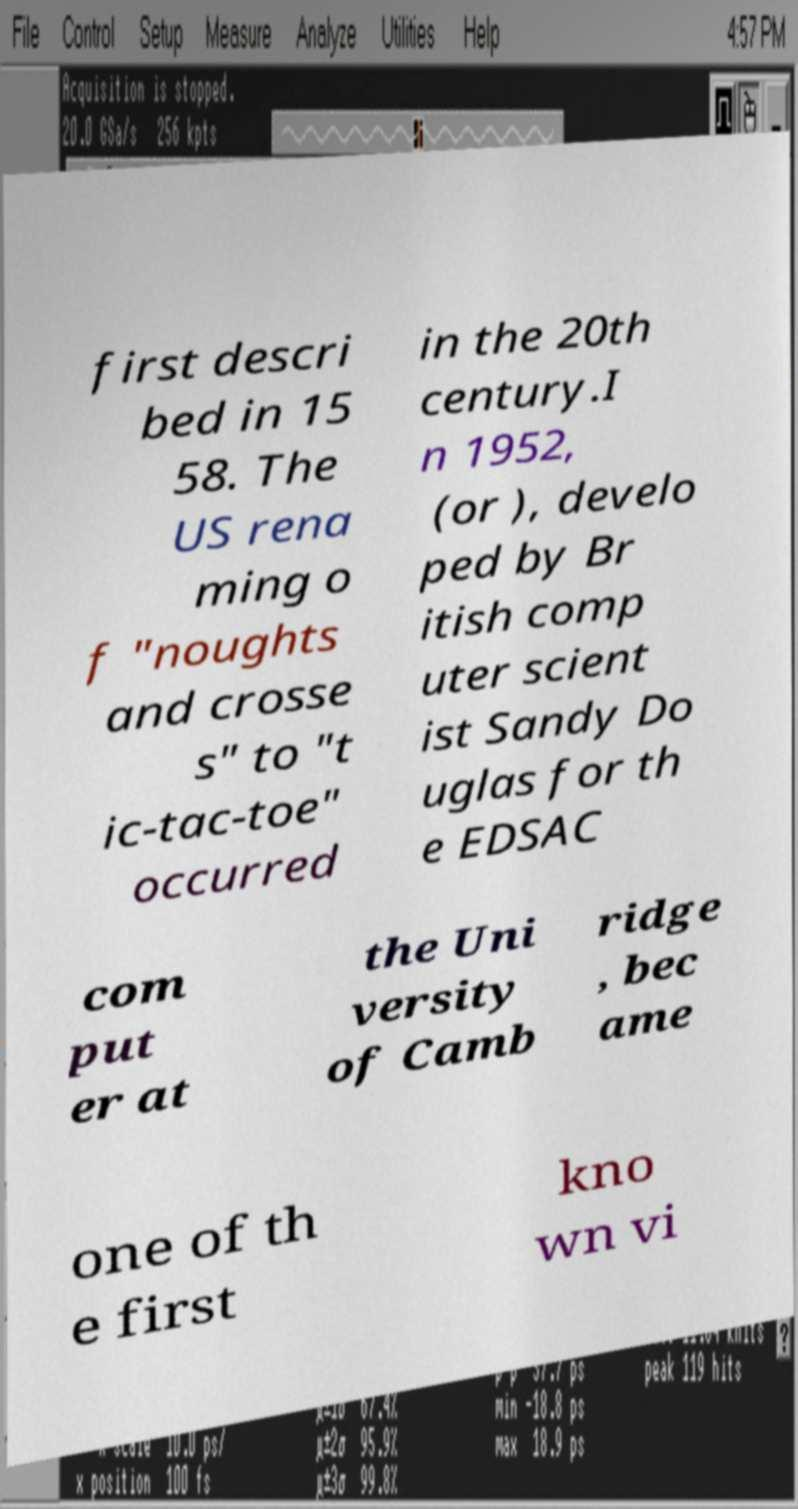What messages or text are displayed in this image? I need them in a readable, typed format. first descri bed in 15 58. The US rena ming o f "noughts and crosse s" to "t ic-tac-toe" occurred in the 20th century.I n 1952, (or ), develo ped by Br itish comp uter scient ist Sandy Do uglas for th e EDSAC com put er at the Uni versity of Camb ridge , bec ame one of th e first kno wn vi 